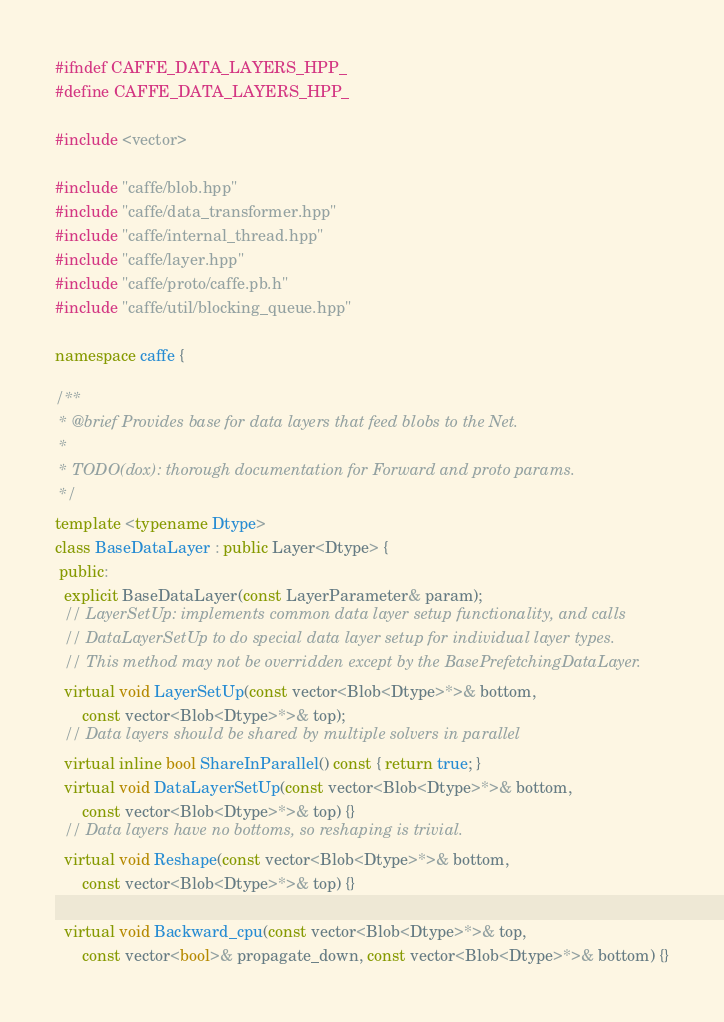Convert code to text. <code><loc_0><loc_0><loc_500><loc_500><_C++_>#ifndef CAFFE_DATA_LAYERS_HPP_
#define CAFFE_DATA_LAYERS_HPP_

#include <vector>

#include "caffe/blob.hpp"
#include "caffe/data_transformer.hpp"
#include "caffe/internal_thread.hpp"
#include "caffe/layer.hpp"
#include "caffe/proto/caffe.pb.h"
#include "caffe/util/blocking_queue.hpp"

namespace caffe {

/**
 * @brief Provides base for data layers that feed blobs to the Net.
 *
 * TODO(dox): thorough documentation for Forward and proto params.
 */
template <typename Dtype>
class BaseDataLayer : public Layer<Dtype> {
 public:
  explicit BaseDataLayer(const LayerParameter& param);
  // LayerSetUp: implements common data layer setup functionality, and calls
  // DataLayerSetUp to do special data layer setup for individual layer types.
  // This method may not be overridden except by the BasePrefetchingDataLayer.
  virtual void LayerSetUp(const vector<Blob<Dtype>*>& bottom,
      const vector<Blob<Dtype>*>& top);
  // Data layers should be shared by multiple solvers in parallel
  virtual inline bool ShareInParallel() const { return true; }
  virtual void DataLayerSetUp(const vector<Blob<Dtype>*>& bottom,
      const vector<Blob<Dtype>*>& top) {}
  // Data layers have no bottoms, so reshaping is trivial.
  virtual void Reshape(const vector<Blob<Dtype>*>& bottom,
      const vector<Blob<Dtype>*>& top) {}

  virtual void Backward_cpu(const vector<Blob<Dtype>*>& top,
      const vector<bool>& propagate_down, const vector<Blob<Dtype>*>& bottom) {}</code> 